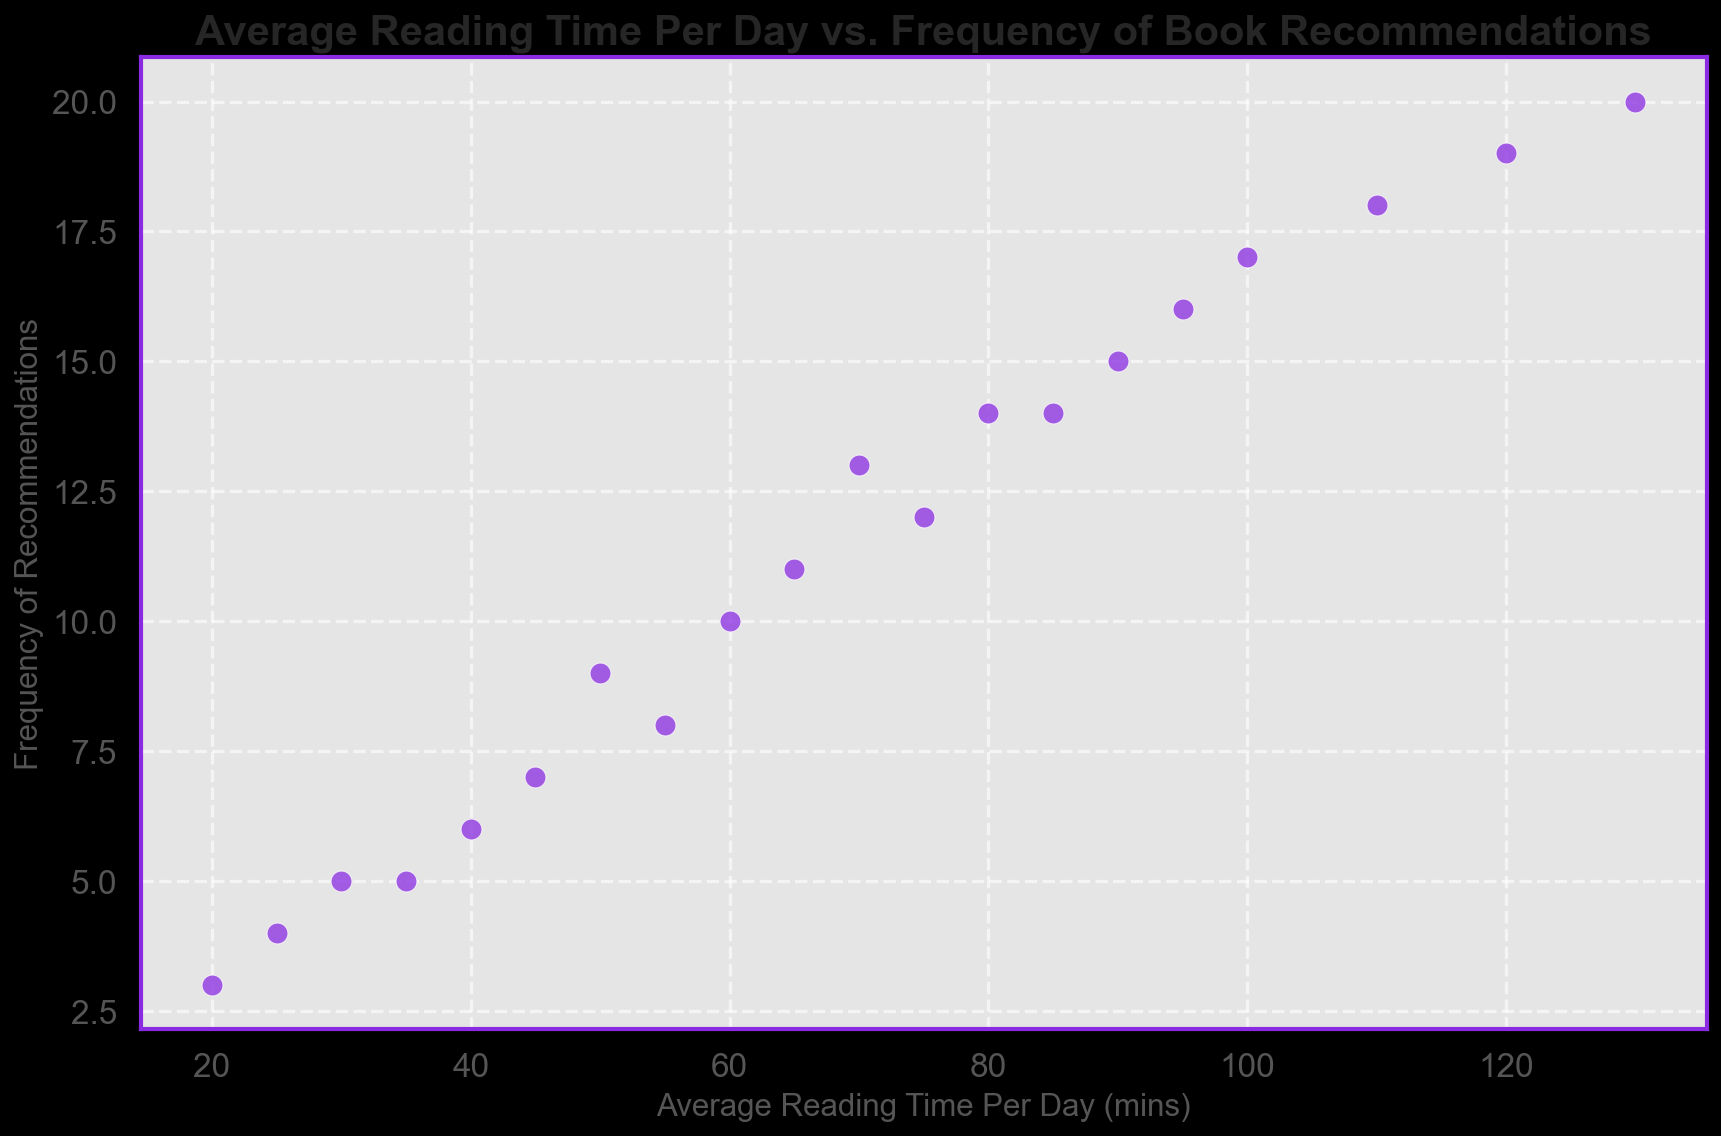What is the average frequency of recommendations for retirees who read 60 minutes per day? To find the average frequency, simply locate the data point in the figure where the average reading time per day is 60 minutes. The corresponding frequency of recommendations is 10.
Answer: 10 What is the difference in frequency of recommendations between retirees who read 95 minutes a day and those who read 35 minutes a day? Identify the data points for 95 and 35 minutes reading time per day from the scatter plot and their respective frequencies. The corresponding frequencies are 16 and 5. The difference is 16 - 5 = 11.
Answer: 11 Which reading time is associated with the highest frequency of recommendations? Visually inspect the scatter plot to identify the highest point on the vertical axis. The highest frequency of recommendations is 20, which corresponds to an average reading time of 130 minutes.
Answer: 130 Is there a general trend between reading time and frequency of recommendations? Inspect the scatter plot and notice the general direction and pattern of data points. There seems to be an upward trend, indicating that as the reading time per day increases, so does the frequency of recommendations.
Answer: Increasing trend What is the median frequency of recommendations for retirees with more than 70 minutes of reading time per day? First, extract the frequencies for retirees reading more than 70 minutes a day. The relevant frequencies are 14, 14, 16, 17, 18, 19, and 20. To find the median, order these values and find the middle number. The ordered sequence is 14, 14, 16, 17, 18, 19, 20. The median is the middle value, which is 17.
Answer: 17 By how much does the frequency of recommendations increase from 75 minutes to 100 minutes of reading time per day? Identify the data points for 75 and 100 minutes reading time per day from the scatter plot. The corresponding frequencies are 12 and 17 respectively. The increase is 17 - 12 = 5.
Answer: 5 What color and marker style are used in the scatter plot? Visually inspect the scatter plot. The markers are purple (blueviolet) circles with white edges.
Answer: Purple circles What's the total frequency of recommendations for retirees who read 55 minutes and 25 minutes per day combined? Identify the data points for 55 and 25 minutes reading time per day from the scatter plot. The corresponding frequencies are 8 and 4. The sum is 8 + 4 = 12.
Answer: 12 Are there any retirees who read more than 100 minutes per day? If so, how many recommendations do they make? Inspect the scatter plot for data points beyond the 100-minute mark on the horizontal axis. There are three data points at 110, 120, and 130 minutes, corresponding to frequencies of 18, 19, and 20 respectively.
Answer: Yes, 18, 19, 20 